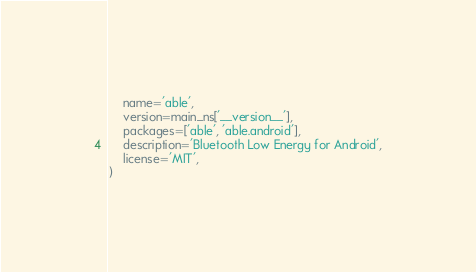<code> <loc_0><loc_0><loc_500><loc_500><_Python_>    name='able',
    version=main_ns['__version__'],
    packages=['able', 'able.android'],
    description='Bluetooth Low Energy for Android',
    license='MIT',
)
</code> 